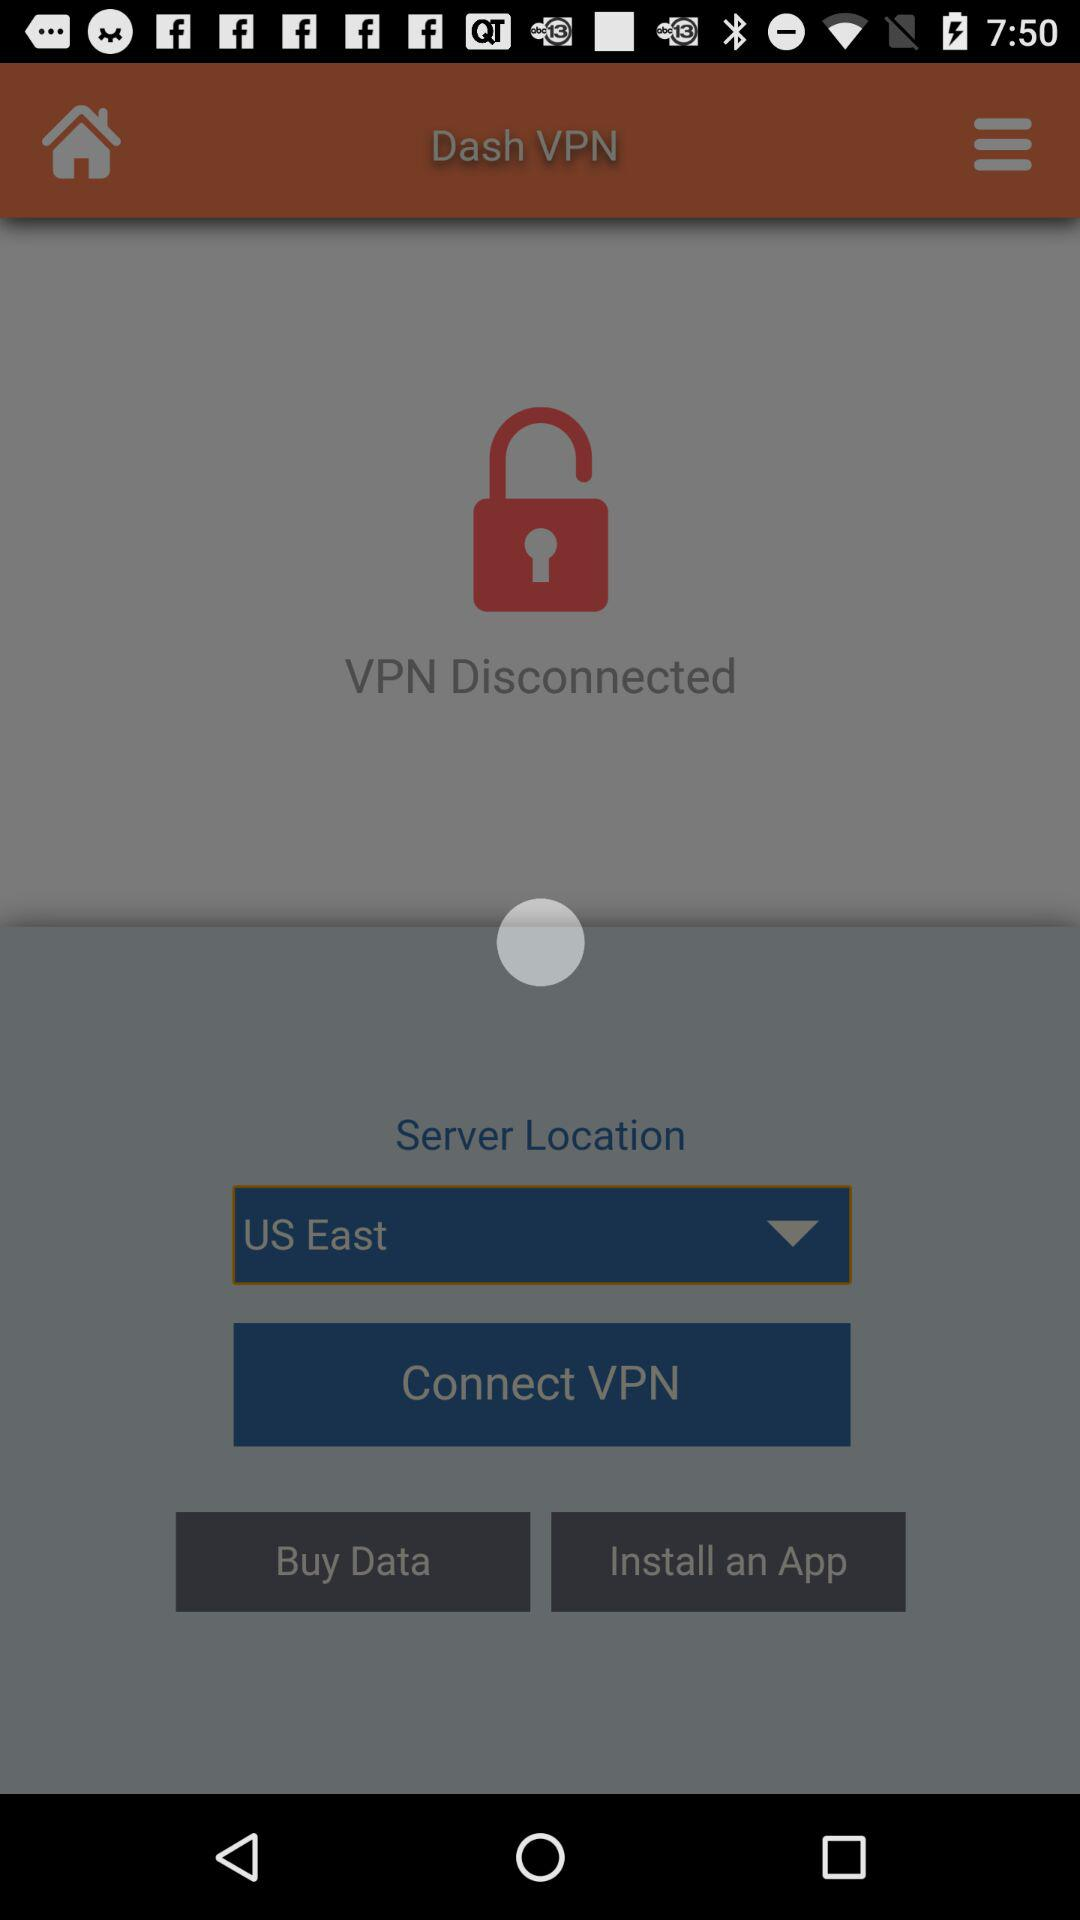What is the status of the VPN? The status of the VPN is "Disconnected". 